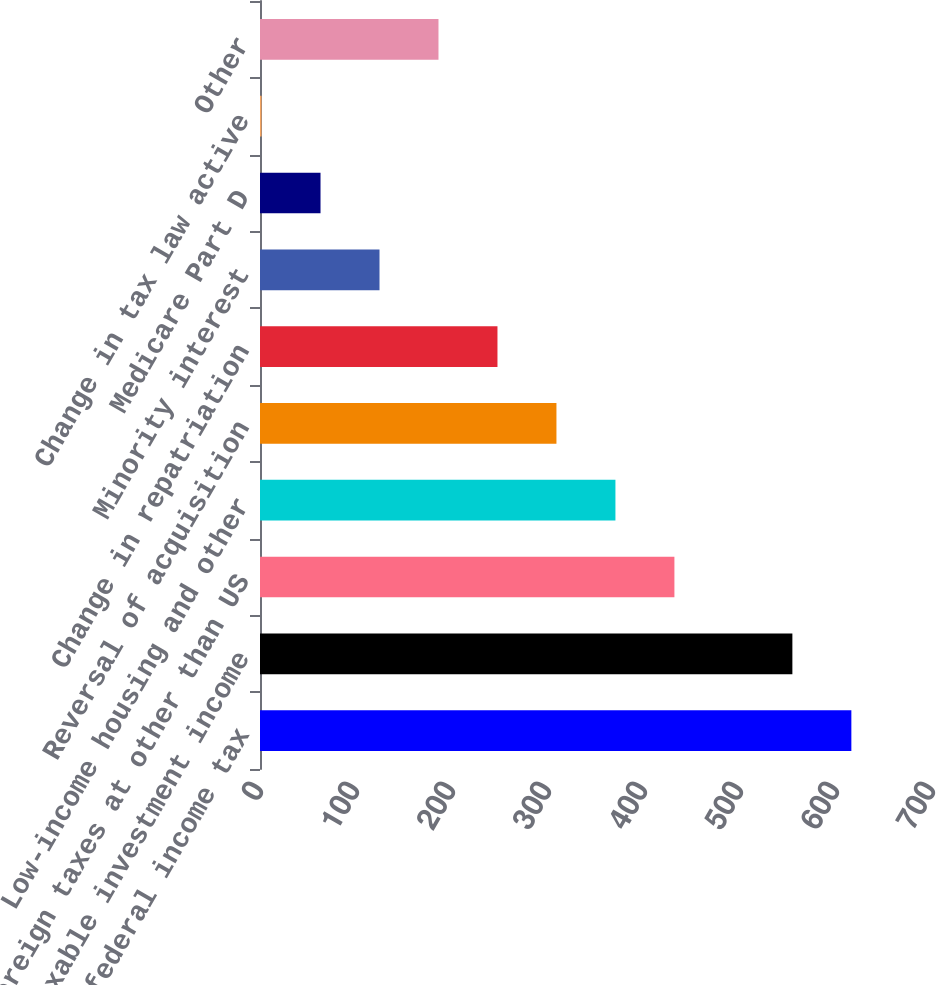Convert chart. <chart><loc_0><loc_0><loc_500><loc_500><bar_chart><fcel>Expected federal income tax<fcel>Non-taxable investment income<fcel>Foreign taxes at other than US<fcel>Low-income housing and other<fcel>Reversal of acquisition<fcel>Change in repatriation<fcel>Minority interest<fcel>Medicare Part D<fcel>Change in tax law active<fcel>Other<nl><fcel>616<fcel>554.56<fcel>431.68<fcel>370.24<fcel>308.8<fcel>247.36<fcel>124.48<fcel>63.04<fcel>1.6<fcel>185.92<nl></chart> 